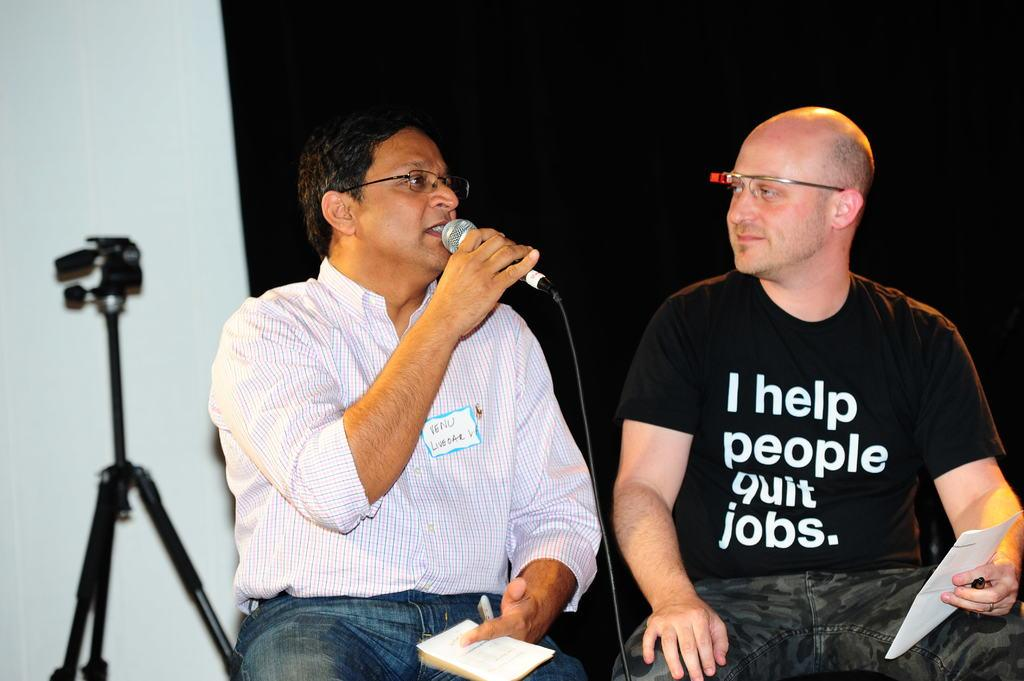What is the color of the wall in the image? The wall in the image is white. What are the two people in the image doing? The two people are sitting on chairs in the image. What is one of the people holding? One of the people is holding a mic. Where is the camera located in the image? The camera is on the left side of the image. What type of profit can be seen being exchanged between the two people in the image? There is no exchange of profit visible in the image; the two people are sitting on chairs and one is holding a mic. 